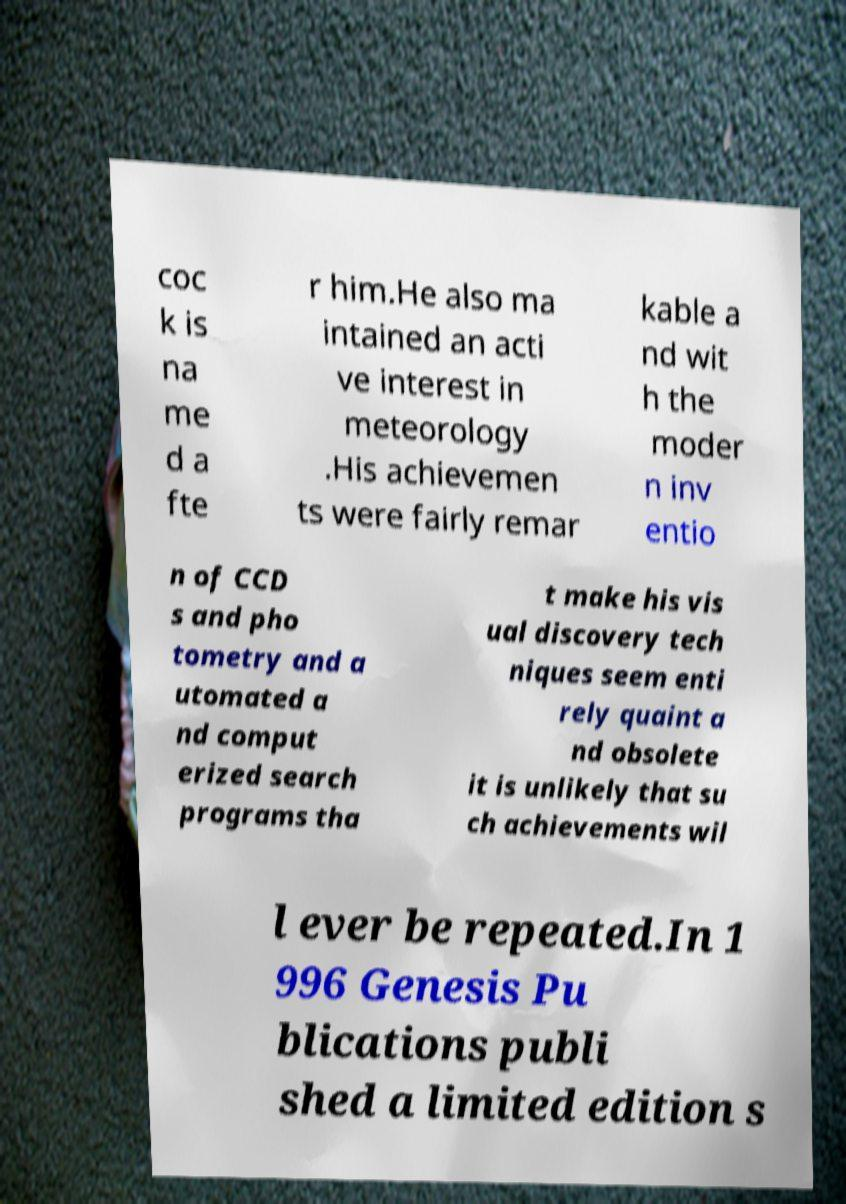Can you read and provide the text displayed in the image?This photo seems to have some interesting text. Can you extract and type it out for me? coc k is na me d a fte r him.He also ma intained an acti ve interest in meteorology .His achievemen ts were fairly remar kable a nd wit h the moder n inv entio n of CCD s and pho tometry and a utomated a nd comput erized search programs tha t make his vis ual discovery tech niques seem enti rely quaint a nd obsolete it is unlikely that su ch achievements wil l ever be repeated.In 1 996 Genesis Pu blications publi shed a limited edition s 